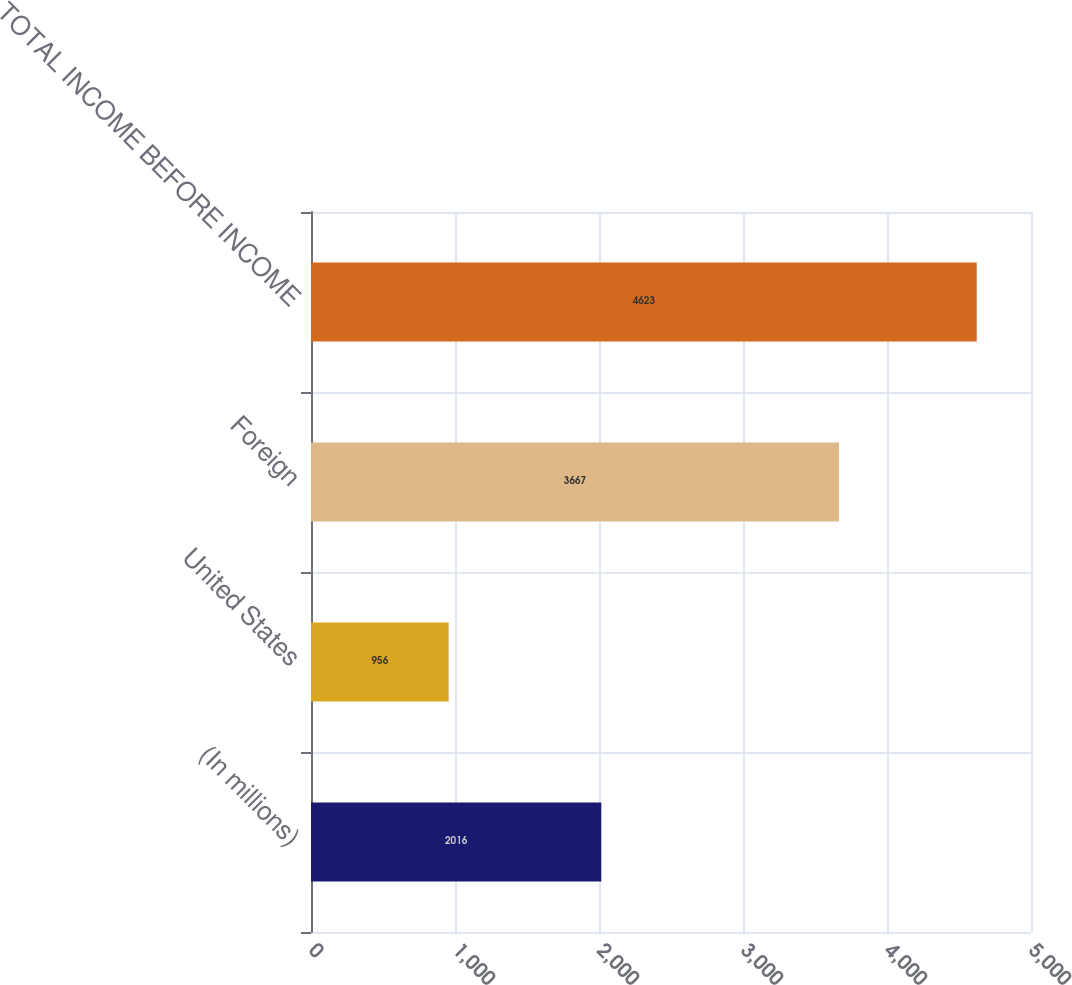Convert chart to OTSL. <chart><loc_0><loc_0><loc_500><loc_500><bar_chart><fcel>(In millions)<fcel>United States<fcel>Foreign<fcel>TOTAL INCOME BEFORE INCOME<nl><fcel>2016<fcel>956<fcel>3667<fcel>4623<nl></chart> 